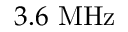Convert formula to latex. <formula><loc_0><loc_0><loc_500><loc_500>3 . 6 M H z</formula> 